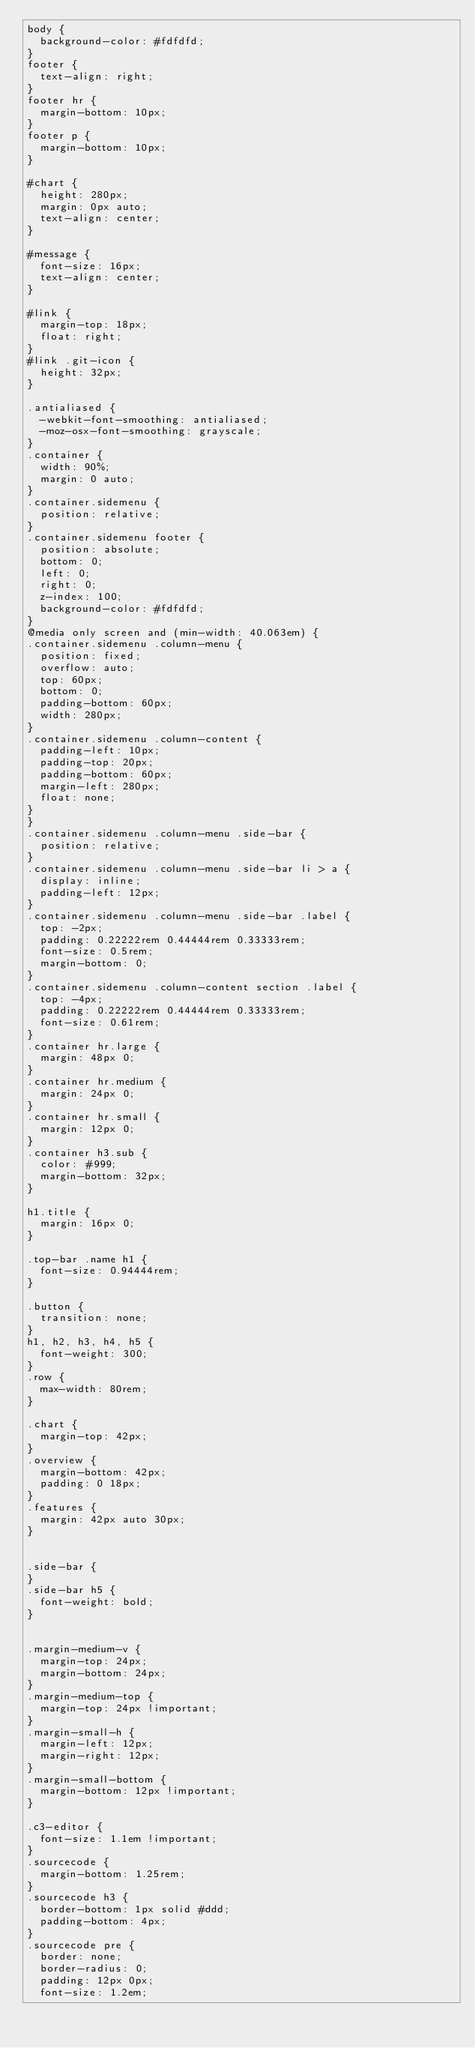<code> <loc_0><loc_0><loc_500><loc_500><_CSS_>body {
  background-color: #fdfdfd;
}
footer {
  text-align: right;
}
footer hr {
  margin-bottom: 10px;
}
footer p {
  margin-bottom: 10px;
}

#chart {
  height: 280px;
  margin: 0px auto;
  text-align: center;
}

#message {
  font-size: 16px;
  text-align: center;
}

#link {
  margin-top: 18px;
  float: right;
}
#link .git-icon {
  height: 32px;
}

.antialiased {
  -webkit-font-smoothing: antialiased;
  -moz-osx-font-smoothing: grayscale;
}
.container {
  width: 90%;
  margin: 0 auto;
}
.container.sidemenu {
  position: relative;
}
.container.sidemenu footer {
  position: absolute;
  bottom: 0;
  left: 0;
  right: 0;
  z-index: 100;
  background-color: #fdfdfd;
}
@media only screen and (min-width: 40.063em) {
.container.sidemenu .column-menu {
  position: fixed;
  overflow: auto;
  top: 60px;
  bottom: 0;
  padding-bottom: 60px;
  width: 280px;
}
.container.sidemenu .column-content {
  padding-left: 10px;
  padding-top: 20px;
  padding-bottom: 60px;
  margin-left: 280px;
  float: none;
}
}
.container.sidemenu .column-menu .side-bar {
  position: relative;
}
.container.sidemenu .column-menu .side-bar li > a {
  display: inline;
  padding-left: 12px;
}
.container.sidemenu .column-menu .side-bar .label {
  top: -2px;
  padding: 0.22222rem 0.44444rem 0.33333rem;
  font-size: 0.5rem;
  margin-bottom: 0;
}
.container.sidemenu .column-content section .label {
  top: -4px;
  padding: 0.22222rem 0.44444rem 0.33333rem;
  font-size: 0.61rem;
}
.container hr.large {
  margin: 48px 0;
}
.container hr.medium {
  margin: 24px 0;
}
.container hr.small {
  margin: 12px 0;
}
.container h3.sub {
  color: #999;
  margin-bottom: 32px;
}

h1.title {
  margin: 16px 0;
}

.top-bar .name h1 {
  font-size: 0.94444rem;
}

.button {
  transition: none;
}
h1, h2, h3, h4, h5 {
  font-weight: 300;
}
.row {
  max-width: 80rem;
}

.chart {
  margin-top: 42px;
}
.overview {
  margin-bottom: 42px;
  padding: 0 18px;
}
.features {
  margin: 42px auto 30px;
}


.side-bar {
}
.side-bar h5 {
  font-weight: bold;
}


.margin-medium-v {
  margin-top: 24px;
  margin-bottom: 24px;
}
.margin-medium-top {
  margin-top: 24px !important;
}
.margin-small-h {
  margin-left: 12px;
  margin-right: 12px;
}
.margin-small-bottom {
  margin-bottom: 12px !important;
}

.c3-editor {
  font-size: 1.1em !important;
}
.sourcecode {
  margin-bottom: 1.25rem;
}
.sourcecode h3 {
  border-bottom: 1px solid #ddd;
  padding-bottom: 4px;
}
.sourcecode pre {
  border: none;
  border-radius: 0;
  padding: 12px 0px;
  font-size: 1.2em;</code> 